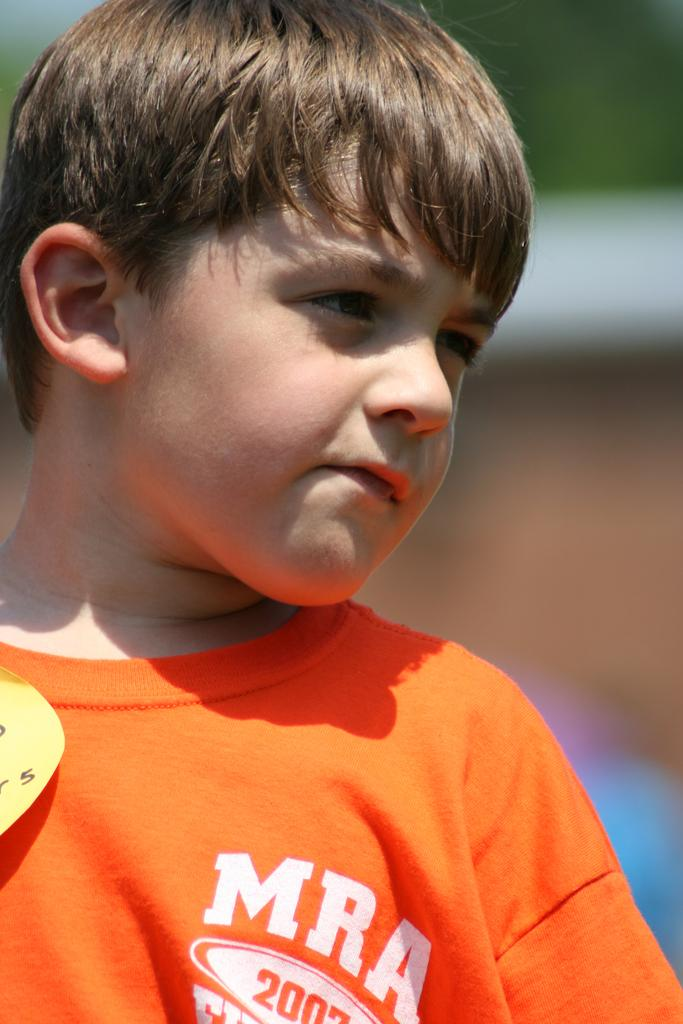What is the main subject of the image? There is a boy in the image. What is the boy wearing? The boy is wearing an orange shirt. What type of ship can be seen in the image? There is no ship present in the image; it features a boy wearing an orange shirt. What disease is the boy suffering from in the image? There is no indication of any disease in the image; it simply shows a boy wearing an orange shirt. 